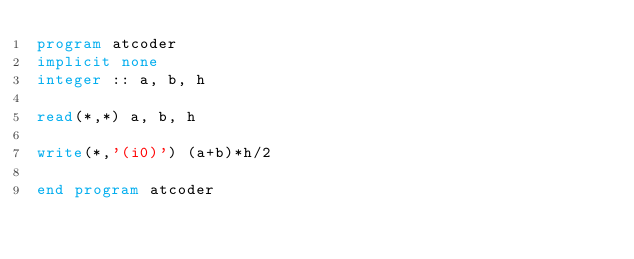<code> <loc_0><loc_0><loc_500><loc_500><_FORTRAN_>program atcoder
implicit none
integer :: a, b, h

read(*,*) a, b, h

write(*,'(i0)') (a+b)*h/2

end program atcoder</code> 